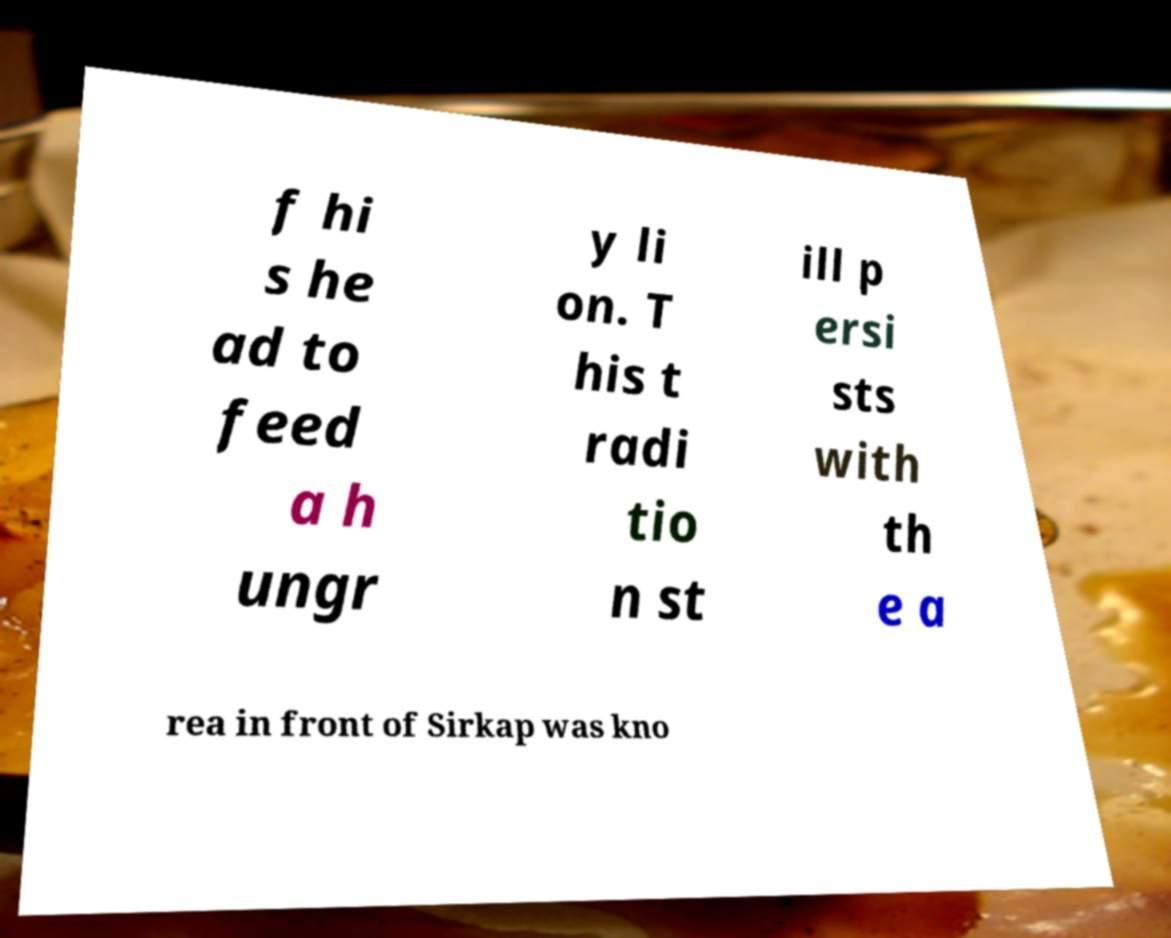Please read and relay the text visible in this image. What does it say? f hi s he ad to feed a h ungr y li on. T his t radi tio n st ill p ersi sts with th e a rea in front of Sirkap was kno 